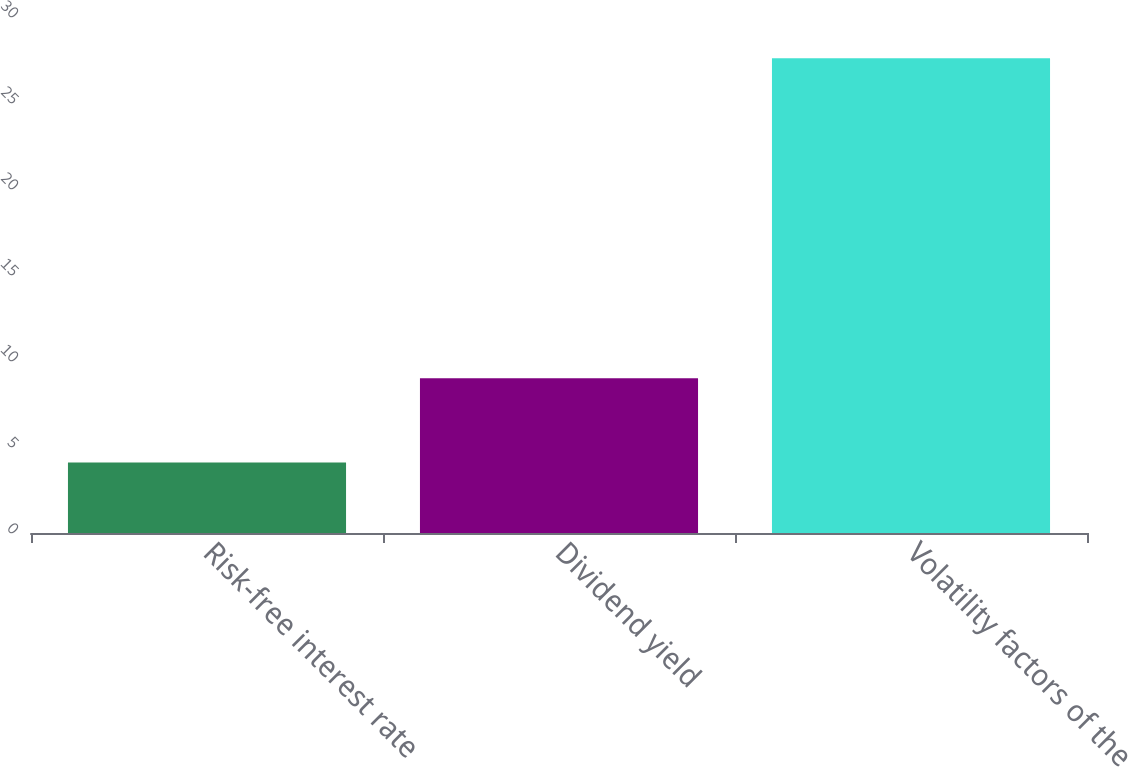Convert chart. <chart><loc_0><loc_0><loc_500><loc_500><bar_chart><fcel>Risk-free interest rate<fcel>Dividend yield<fcel>Volatility factors of the<nl><fcel>4.1<fcel>9<fcel>27.6<nl></chart> 